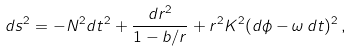<formula> <loc_0><loc_0><loc_500><loc_500>d s ^ { 2 } = - N ^ { 2 } d t ^ { 2 } + \frac { d r ^ { 2 } } { 1 - b / r } + r ^ { 2 } K ^ { 2 } ( d \phi - \omega \, d t ) ^ { 2 } \, ,</formula> 